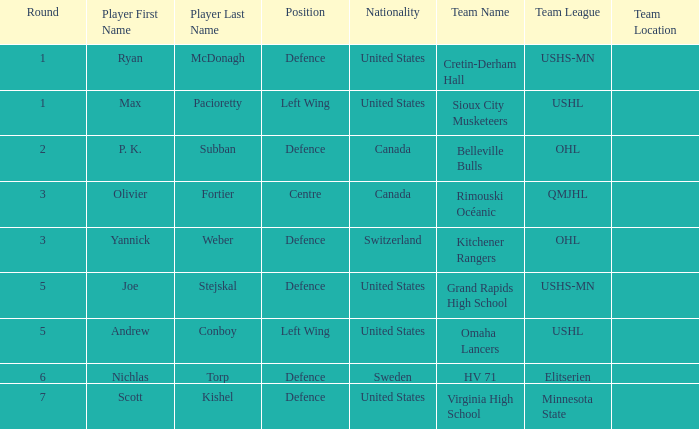Which player from the United States plays defence and was chosen before round 5? Ryan McDonagh. 